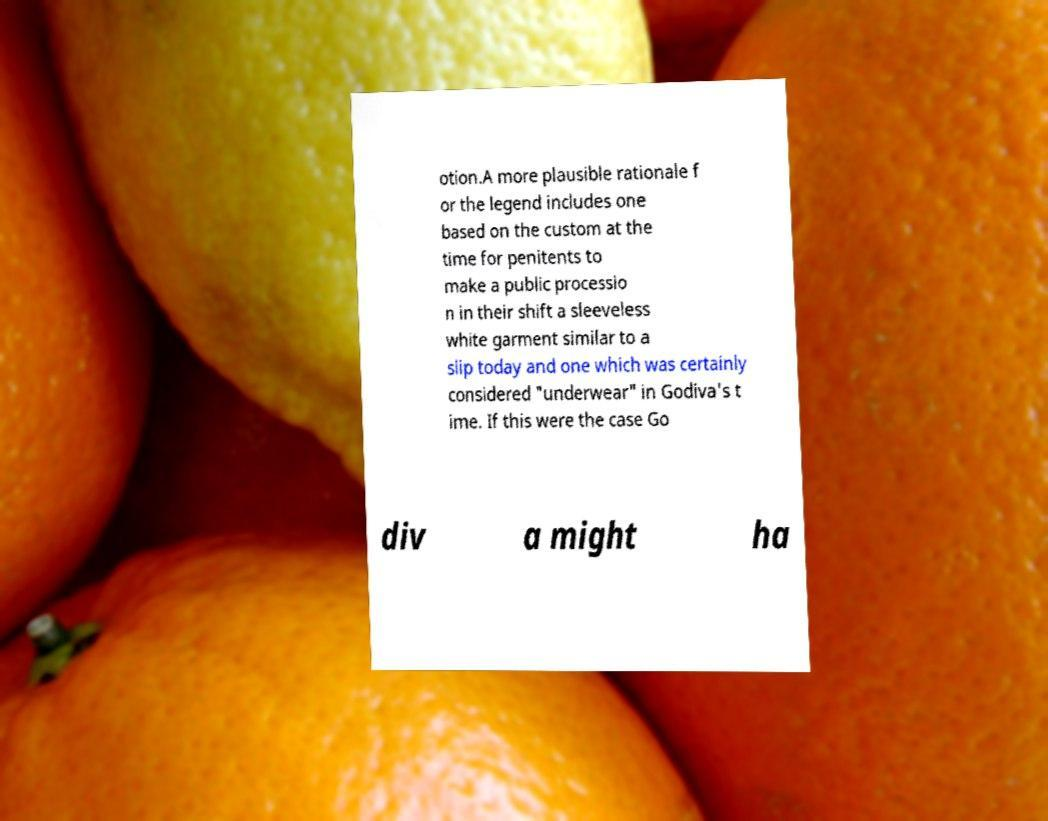For documentation purposes, I need the text within this image transcribed. Could you provide that? otion.A more plausible rationale f or the legend includes one based on the custom at the time for penitents to make a public processio n in their shift a sleeveless white garment similar to a slip today and one which was certainly considered "underwear" in Godiva's t ime. If this were the case Go div a might ha 